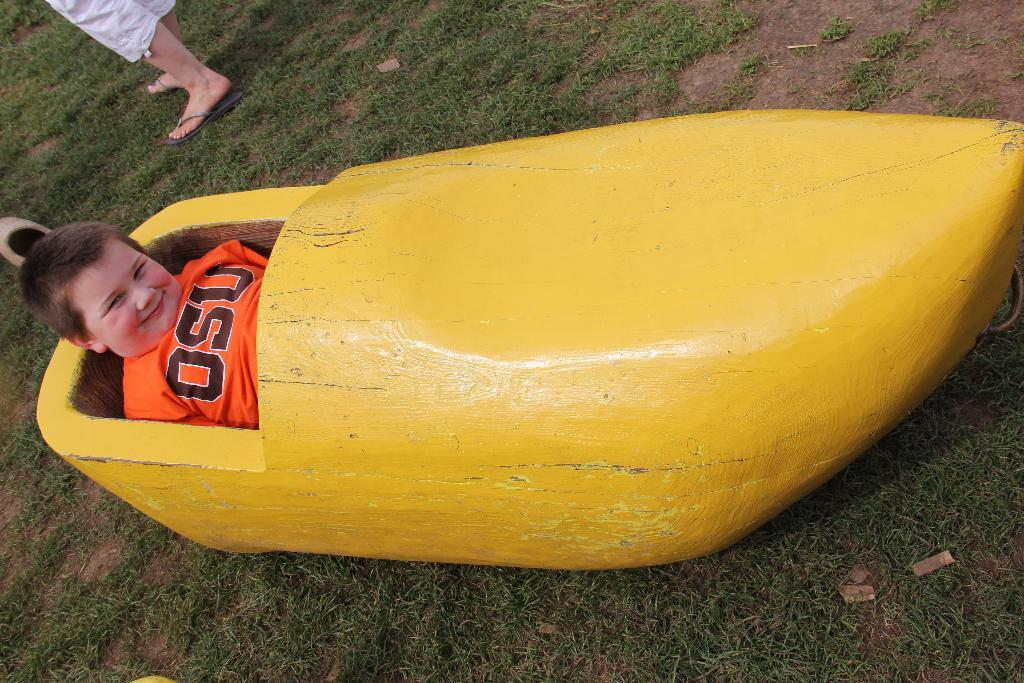<image>
Present a compact description of the photo's key features. A boy wearing an OSU shirt is sitting inside a wooden boat shaped like a banana. 